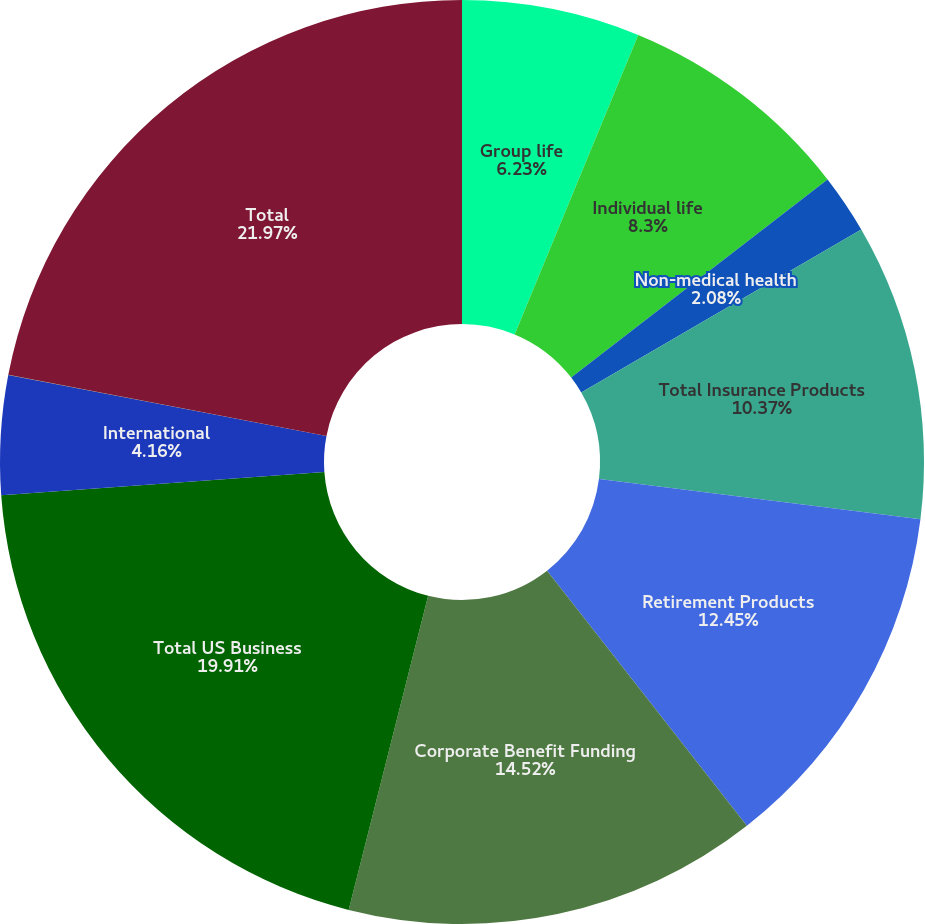<chart> <loc_0><loc_0><loc_500><loc_500><pie_chart><fcel>Group life<fcel>Individual life<fcel>Non-medical health<fcel>Total Insurance Products<fcel>Retirement Products<fcel>Corporate Benefit Funding<fcel>Total US Business<fcel>International<fcel>Banking Corporate & Other<fcel>Total<nl><fcel>6.23%<fcel>8.3%<fcel>2.08%<fcel>10.37%<fcel>12.45%<fcel>14.52%<fcel>19.91%<fcel>4.16%<fcel>0.01%<fcel>21.98%<nl></chart> 